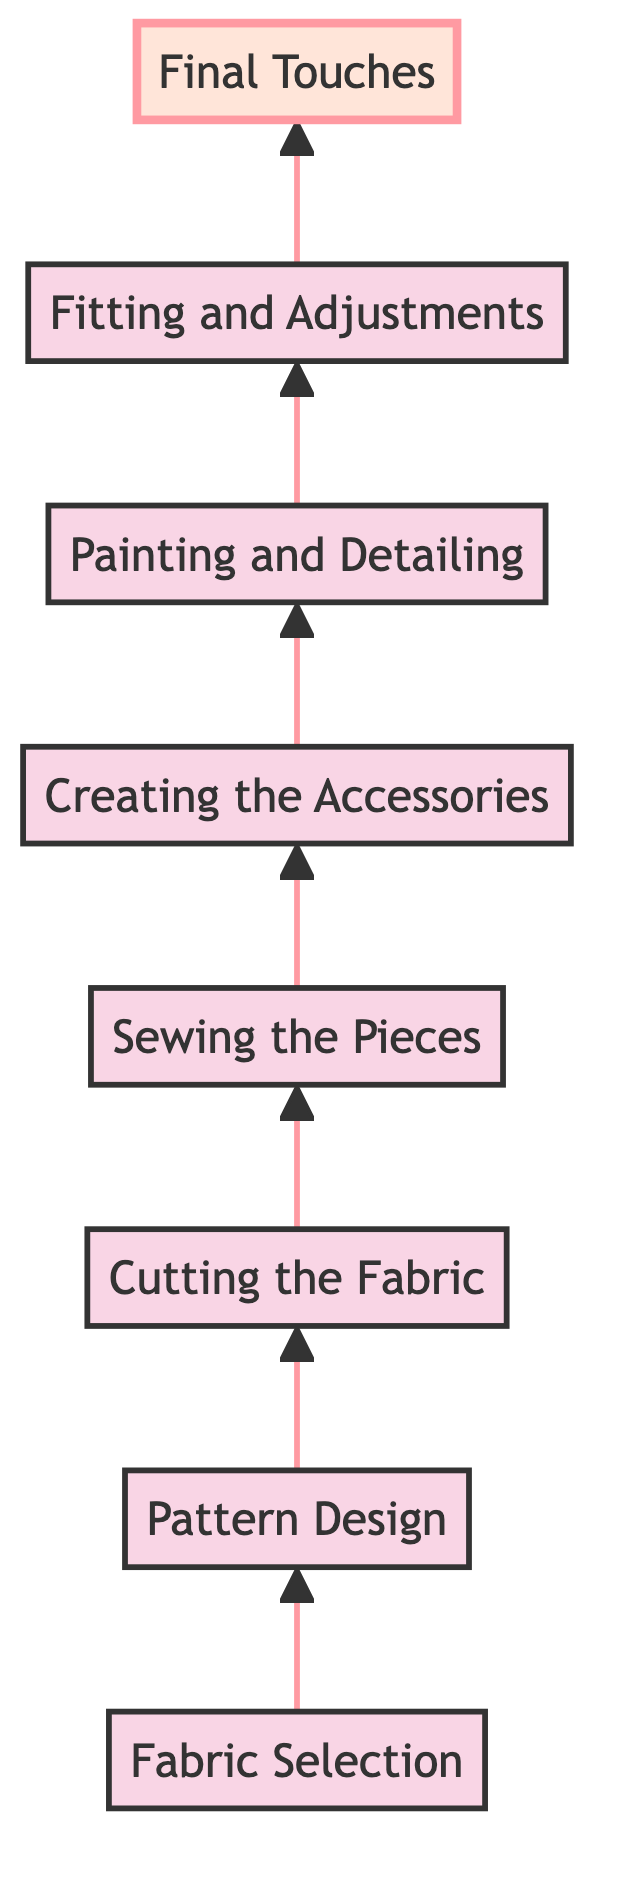What is the first step in creating a Darna-inspired cosplay outfit? The diagram shows that the first step is at the bottom, labeled "Fabric Selection." This is where you begin the process before moving to the next steps.
Answer: Fabric Selection How many steps are there in the creation process? The diagram lists a total of eight steps, from "Fabric Selection" to "Final Touches." By counting each node in the flow chart, we can confirm there are eight distinct steps.
Answer: Eight Which step comes after "Sewing the Pieces"? Following the flow upward from the "Sewing the Pieces" node, the next step is clearly "Creating the Accessories." This defines the order of the creation process.
Answer: Creating the Accessories What is the final step in the cosplay outfit creation? The topmost node in the diagram indicates that the last step is "Final Touches." This is where you add the finishing details to the costume.
Answer: Final Touches What step involves working with patterns for the outfit? The diagram identifies "Pattern Design" as the step focused on patterns, which directly follows "Fabric Selection." This is key to ensuring the outfit is structured properly.
Answer: Pattern Design Which two steps should be completed before "Fitting and Adjustments"? By tracing the flow upward, we find the two preceding steps to "Fitting and Adjustments" are "Painting and Detailing" and "Creating the Accessories." This shows the order needed before fitting.
Answer: Painting and Detailing, Creating the Accessories What are the last two steps in the flow? The final two nodes according to the diagram are "Fitting and Adjustments" followed by "Final Touches." These steps mark the conclusion of the outfit creation process.
Answer: Fitting and Adjustments, Final Touches Which step requires the use of a sewing machine or hand sewing? The node "Sewing the Pieces" specifies this requirement, indicating it is crucial for assembling the cosplay outfit from the cut fabric pieces.
Answer: Sewing the Pieces What is the main focus of the step labeled "Painting and Detailing"? According to the flow chart, this step is primarily about painting the accessories and adding intricate details, indicating its importance for finishing touches in the outfit.
Answer: Painting and Detailing 